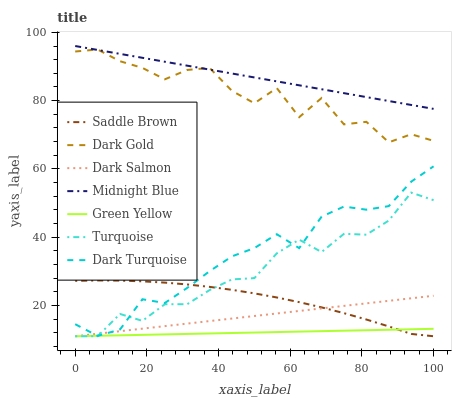Does Green Yellow have the minimum area under the curve?
Answer yes or no. Yes. Does Midnight Blue have the maximum area under the curve?
Answer yes or no. Yes. Does Dark Gold have the minimum area under the curve?
Answer yes or no. No. Does Dark Gold have the maximum area under the curve?
Answer yes or no. No. Is Dark Salmon the smoothest?
Answer yes or no. Yes. Is Dark Gold the roughest?
Answer yes or no. Yes. Is Midnight Blue the smoothest?
Answer yes or no. No. Is Midnight Blue the roughest?
Answer yes or no. No. Does Turquoise have the lowest value?
Answer yes or no. Yes. Does Dark Gold have the lowest value?
Answer yes or no. No. Does Midnight Blue have the highest value?
Answer yes or no. Yes. Does Dark Gold have the highest value?
Answer yes or no. No. Is Turquoise less than Dark Gold?
Answer yes or no. Yes. Is Dark Gold greater than Dark Salmon?
Answer yes or no. Yes. Does Dark Turquoise intersect Green Yellow?
Answer yes or no. Yes. Is Dark Turquoise less than Green Yellow?
Answer yes or no. No. Is Dark Turquoise greater than Green Yellow?
Answer yes or no. No. Does Turquoise intersect Dark Gold?
Answer yes or no. No. 